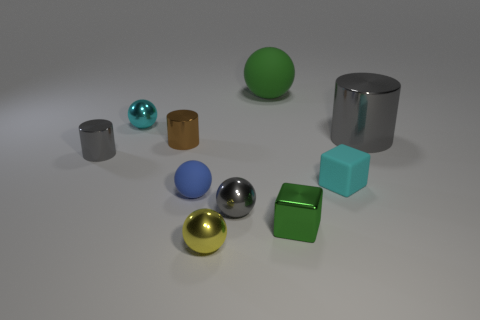If this image were used for an educational purpose, what concept might it be demonstrating? This image could be used to teach concepts related to geometry, such as identifying different 3D shapes and comparing sizes. Additionally, it could serve as a visual aid in discussions about materials and their properties, such as reflectivity and texture. 